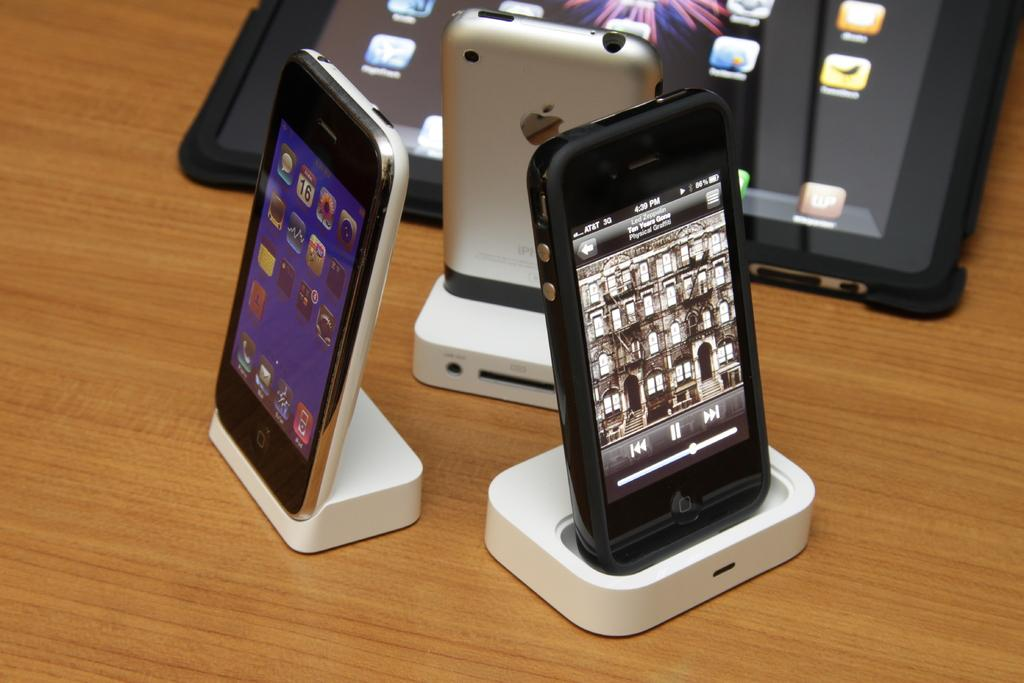<image>
Summarize the visual content of the image. A phone is turned on with a time of 4:39 showing on the screen. 